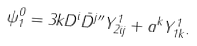Convert formula to latex. <formula><loc_0><loc_0><loc_500><loc_500>\psi _ { 1 } ^ { 0 } = 3 k D ^ { i } \bar { D } ^ { j \prime \prime } Y _ { 2 i j } ^ { 1 } + a ^ { k } Y _ { 1 k } ^ { 1 } .</formula> 